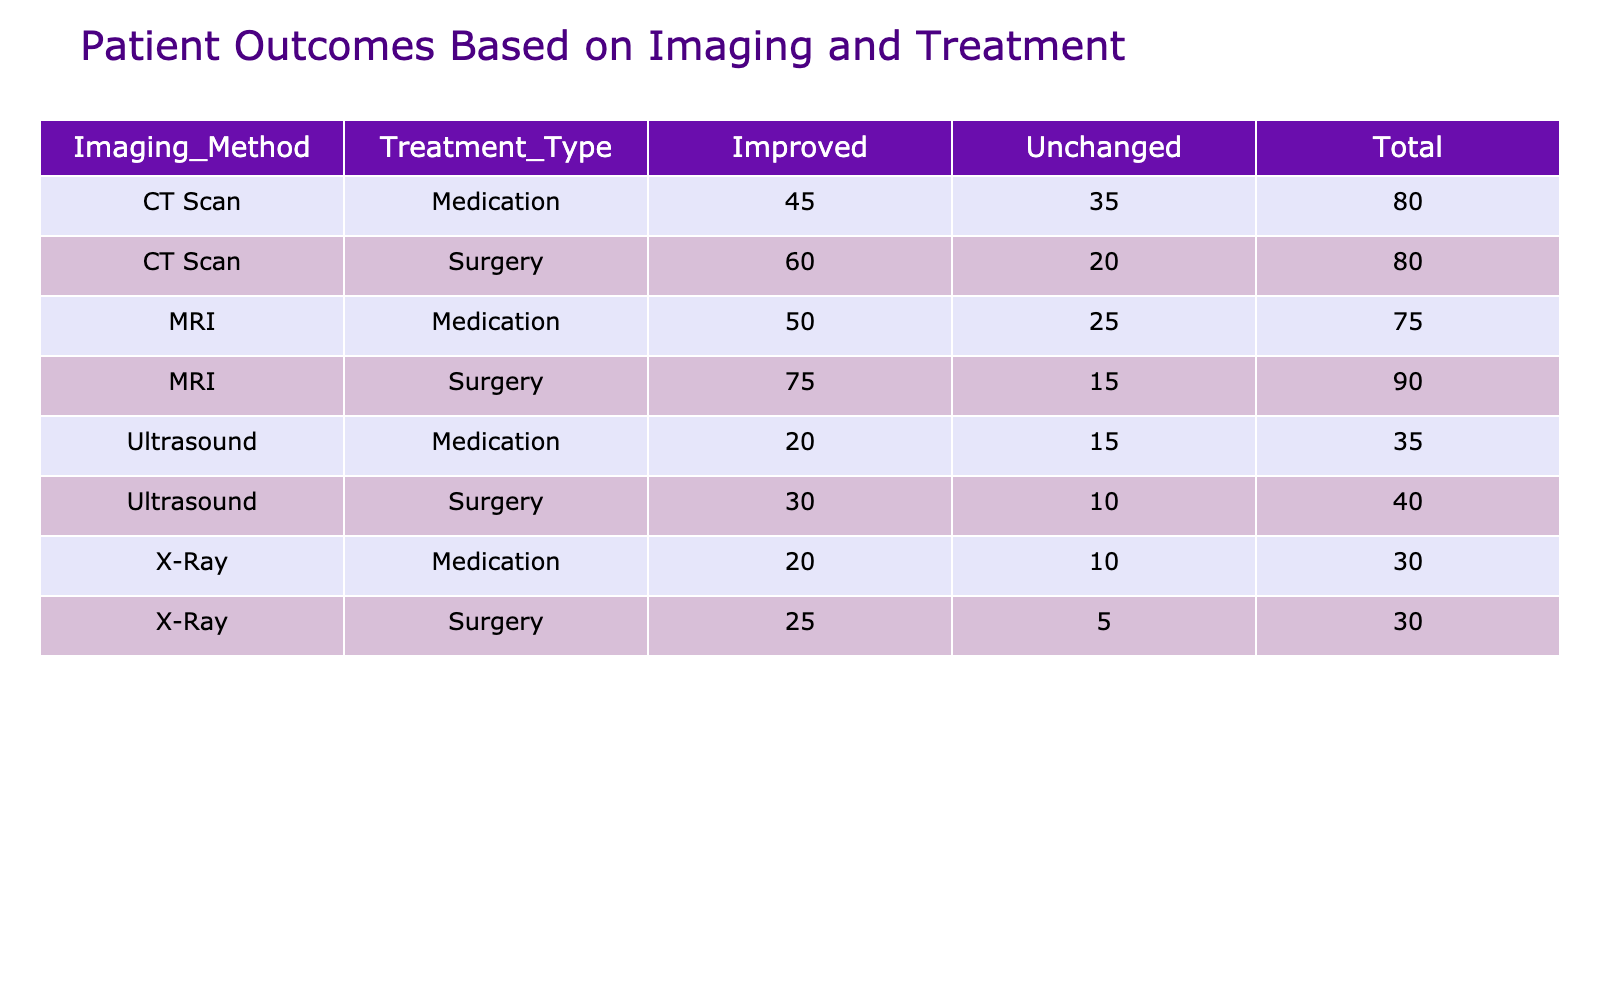What is the total number of patients whose outcomes improved after surgery using MRI? Looking at the table, for MRI and Surgery, the number of patients with an 'Improved' outcome is 75. Therefore, the total number of patients whose outcomes improved after surgery using MRI is 75.
Answer: 75 Which imaging method had the highest number of patients who remained unchanged after treatment? By checking the 'Unchanged' outcomes across all imaging methods, MRI had 15 patients, CT Scan had 20 patients, Ultrasound had 10 patients, and X-Ray had 5 patients. CT Scan had the highest number with 20 patients remaining unchanged.
Answer: CT Scan What is the total number of patients who improved after using Medication across all imaging methods? Summing the 'Improved' outcomes under Medication: MRI has 50, CT Scan has 45, Ultrasound has 20, and X-Ray has 20. Adding these values gives us 50 + 45 + 20 + 20 = 135 patients improved after Medication.
Answer: 135 Is it true that more patients improved using Surgery than Medication in total? To check this, we calculate the total improved outcomes for Surgery: MRI improved 75, CT Scan 60, Ultrasound 30, and X-Ray 25, totaling 75 + 60 + 30 + 25 = 190. For Medication: MRI improved 50, CT Scan 45, Ultrasound 20, and X-Ray 20, totaling 50 + 45 + 20 + 20 = 135. Since 190 is greater than 135, it is true that more patients improved using Surgery than Medication.
Answer: Yes What is the difference in the number of patients who improved using CT Scan and those who improved using Ultrasound for Surgery treatments? For Surgery treatments, CT Scan had 60 patients who improved and Ultrasound had 30 patients who improved. The difference is calculated as 60 - 30 = 30.
Answer: 30 How many patients in total underwent Medication treatment regardless of their outcomes? To find the total number of patients who underwent Medication, we add both 'Improved' and 'Unchanged' outcomes across imaging methods: MRI (50 + 25 = 75), CT Scan (45 + 35 = 80), Ultrasound (20 + 15 = 35), and X-Ray (20 + 10 = 30). The total is 75 + 80 + 35 + 30 = 220.
Answer: 220 For which imaging method was the number of unchanged patients using Surgery and Medication combined the highest? By looking at the combined total of unchanged patients under Surgery and Medication: MRI (15 + 25 = 40), CT Scan (20 + 35 = 55), Ultrasound (10 + 15 = 25), X-Ray (5 + 10 = 15). CT Scan has the highest total combined number of unchanged patients with 55.
Answer: CT Scan Did any patients improve after X-Ray treatment? Checking the 'Improved' outcome for the X-Ray treatment, there are 25 patients who improved after Surgery and 20 who improved after Medication. Therefore, yes, there were patients who improved after X-Ray treatment.
Answer: Yes 